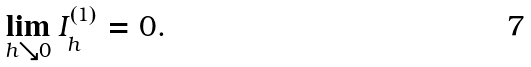Convert formula to latex. <formula><loc_0><loc_0><loc_500><loc_500>\lim _ { h \searrow 0 } I _ { h } ^ { ( 1 ) } = 0 .</formula> 